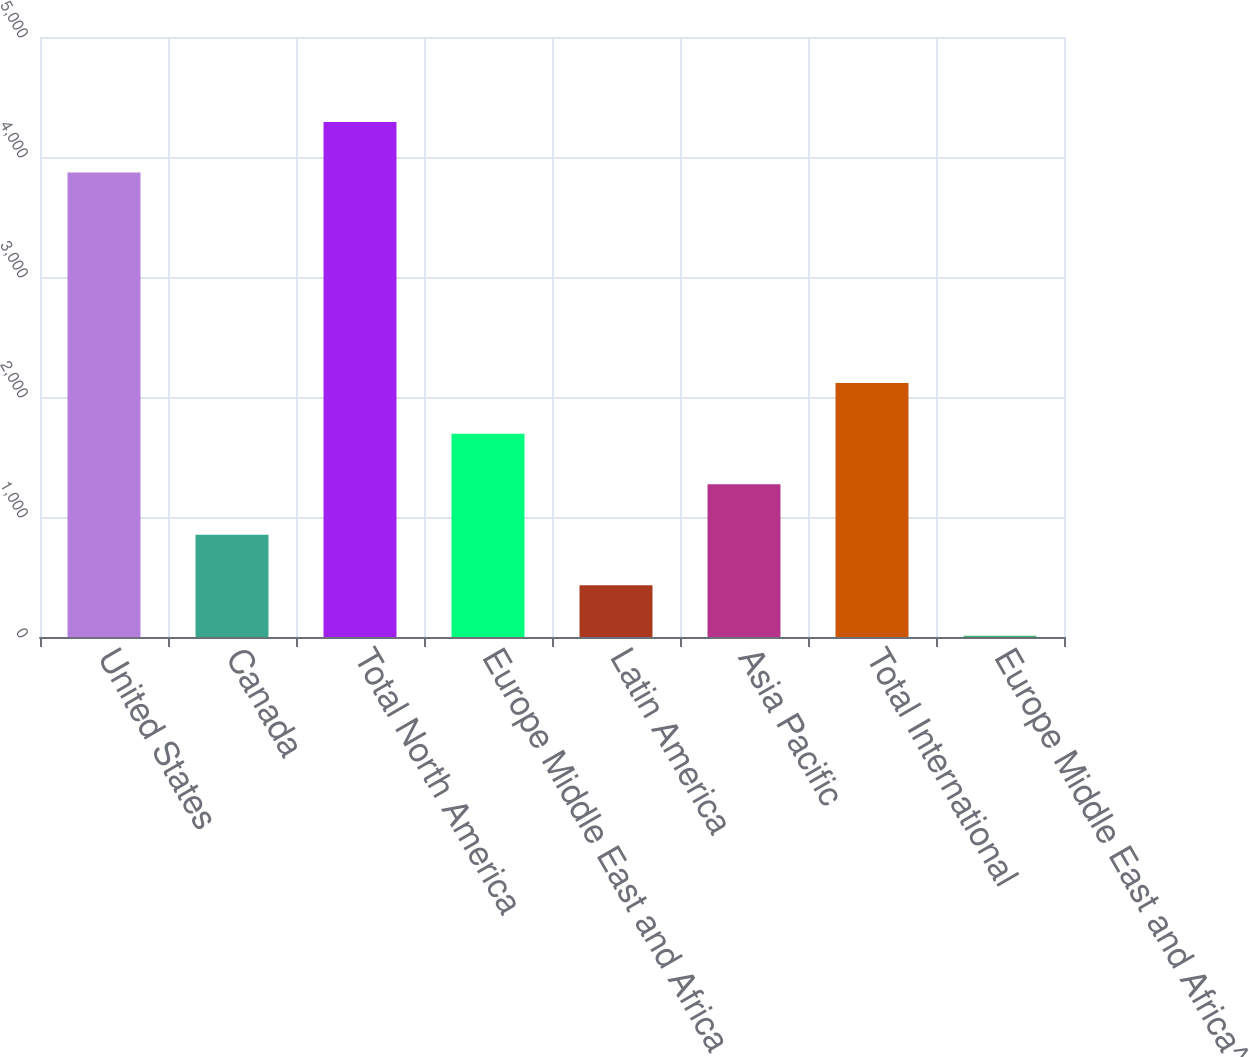Convert chart. <chart><loc_0><loc_0><loc_500><loc_500><bar_chart><fcel>United States<fcel>Canada<fcel>Total North America<fcel>Europe Middle East and Africa<fcel>Latin America<fcel>Asia Pacific<fcel>Total International<fcel>Europe Middle East and Africa^<nl><fcel>3870.3<fcel>852.26<fcel>4291.43<fcel>1694.52<fcel>431.13<fcel>1273.39<fcel>2115.65<fcel>10<nl></chart> 